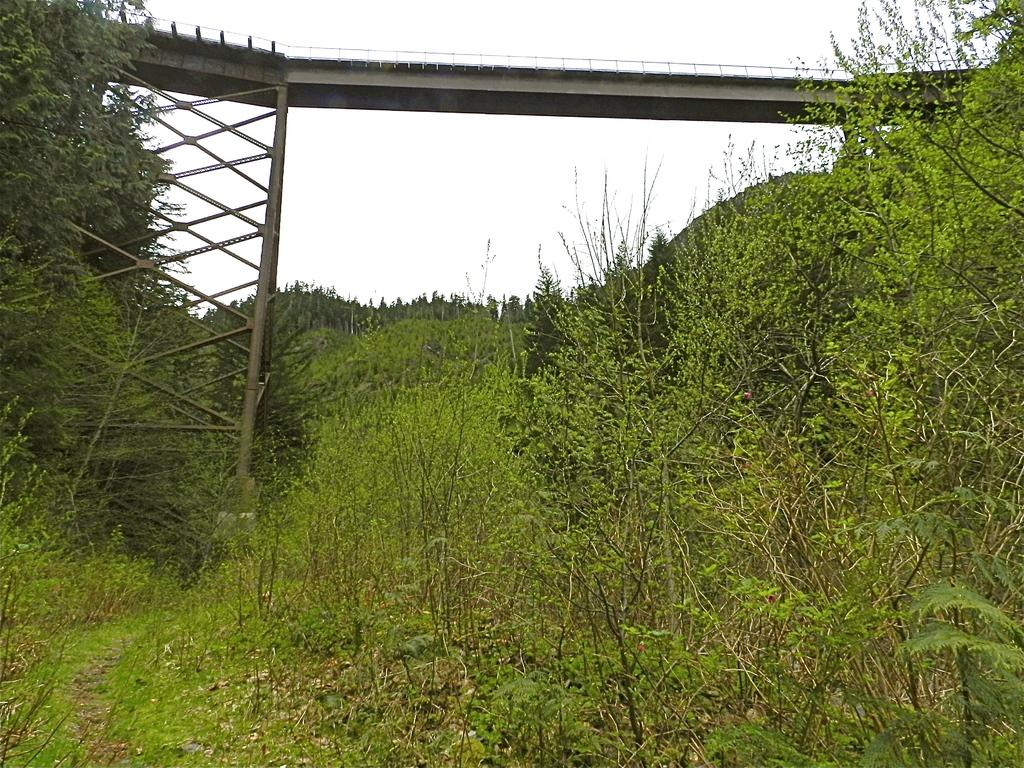What type of natural elements can be seen in the image? There are many trees and plants in the image. What structure is visible at the top of the image? There is a bridge at the top of the image. What is visible in the background of the image? The sky is visible in the image. What type of pollution can be seen in the image? There is no pollution visible in the image; it features trees, plants, a bridge, and the sky. How many pairs of underwear are hanging on the trees in the image? There are no underwear present in the image; it features trees, plants, a bridge, and the sky. 